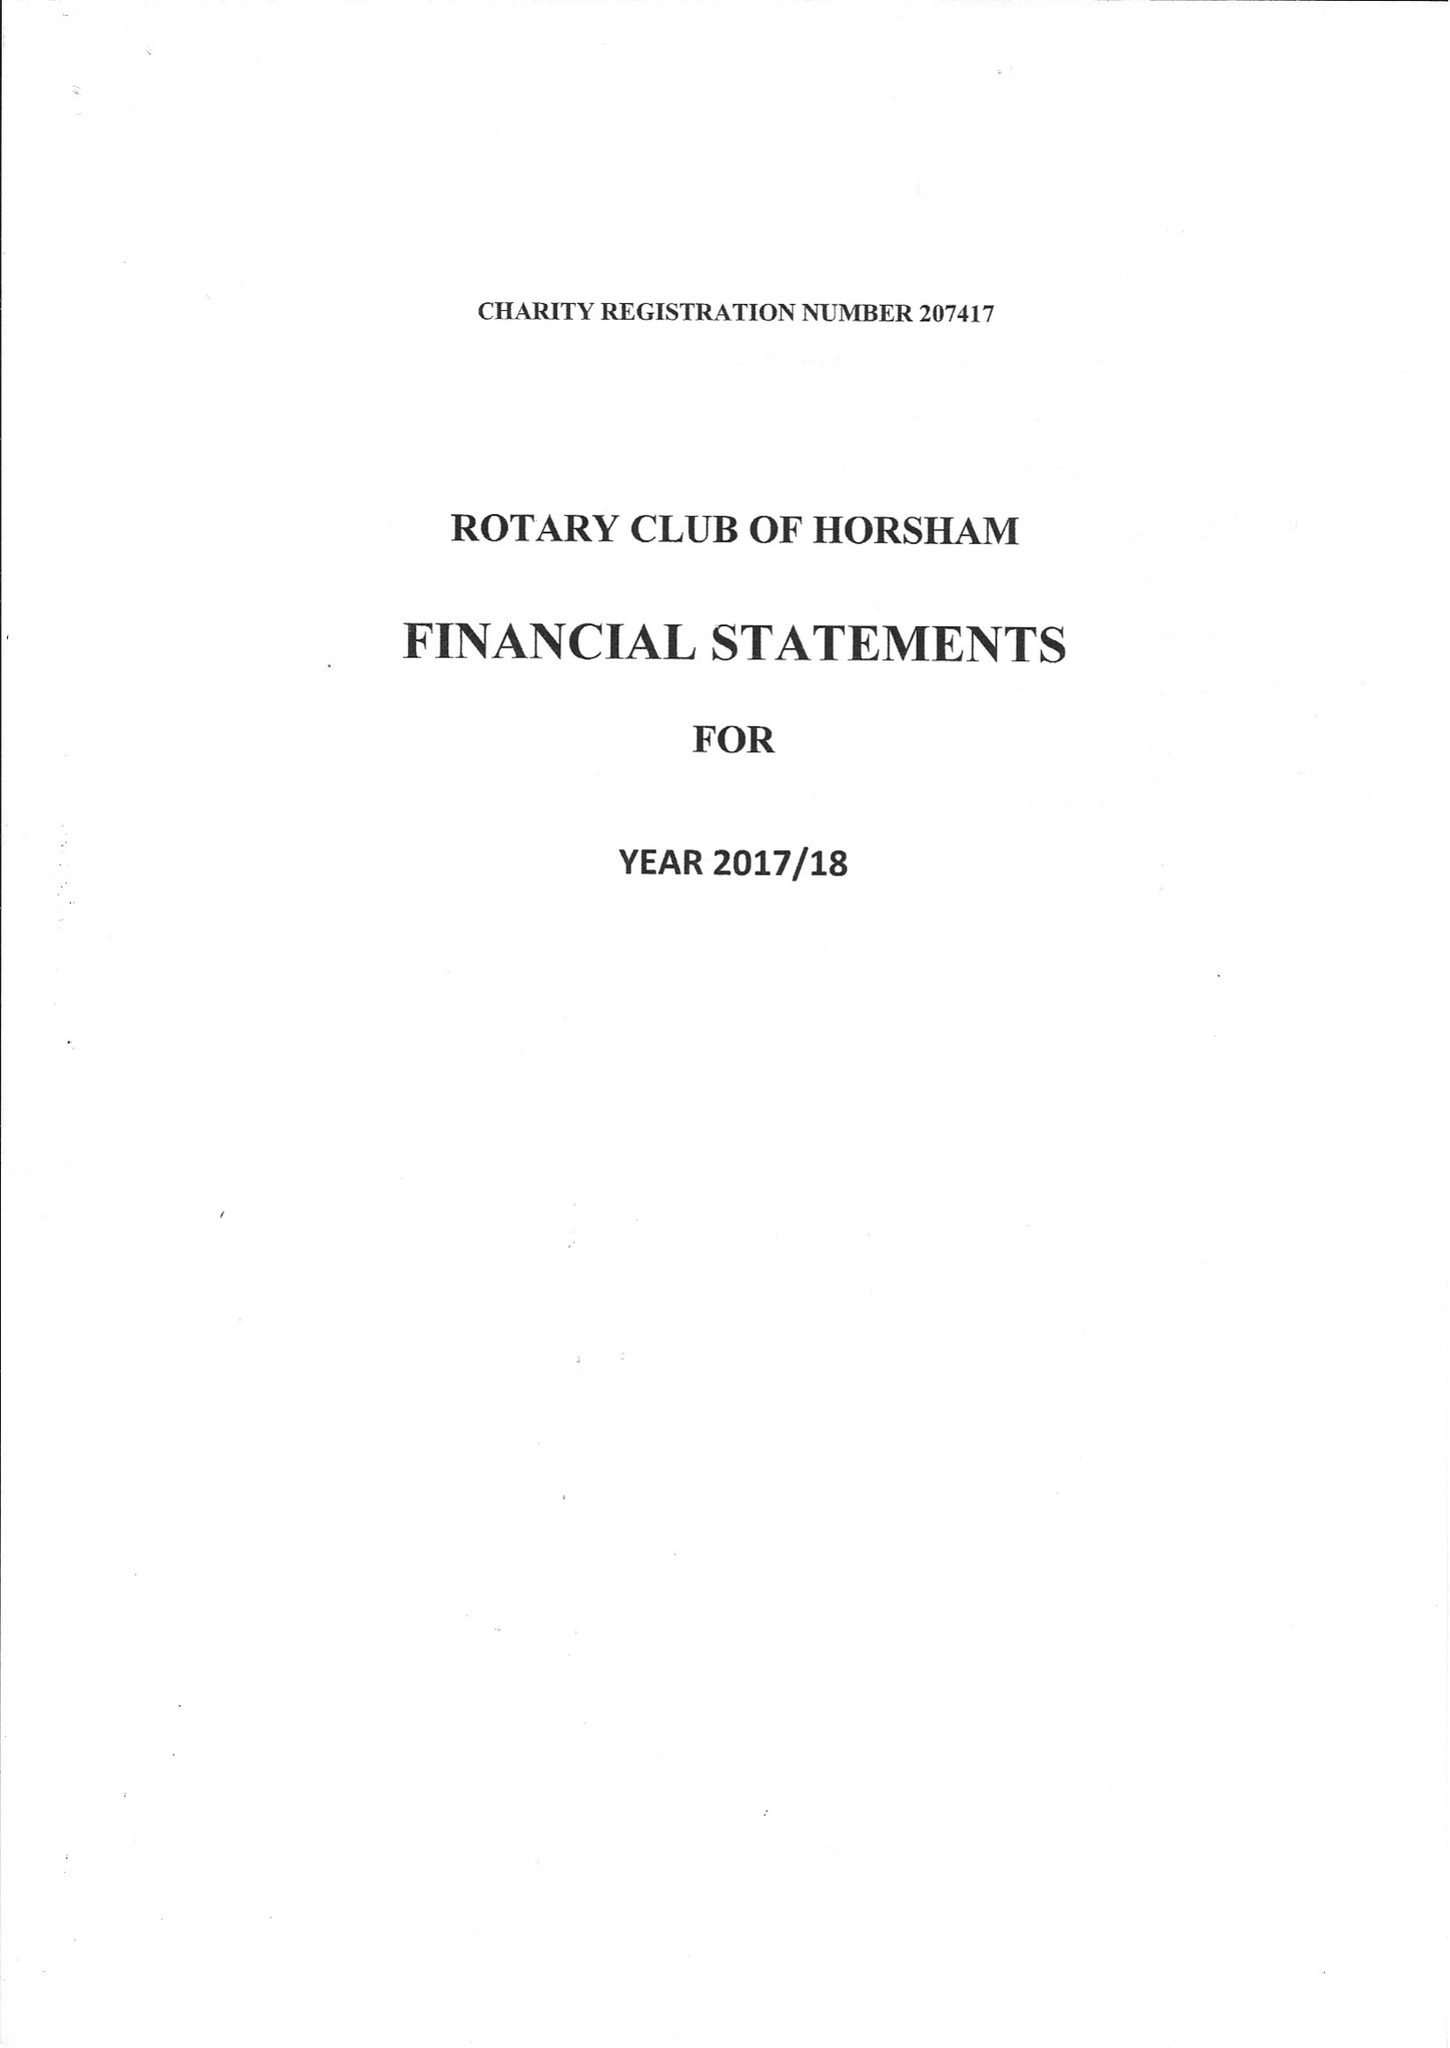What is the value for the address__postcode?
Answer the question using a single word or phrase. RH5 5AR 